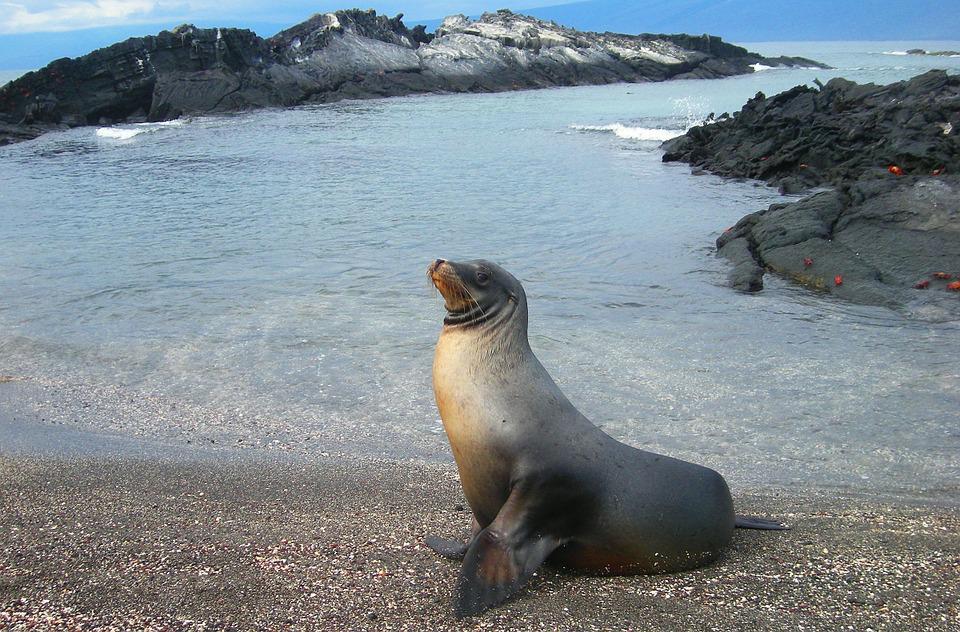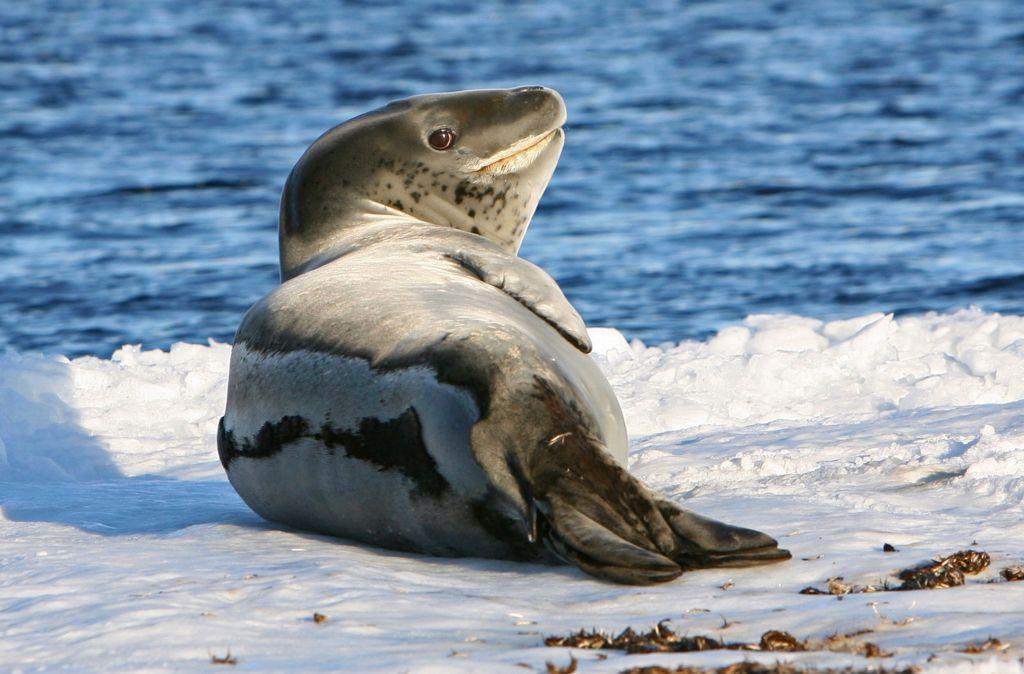The first image is the image on the left, the second image is the image on the right. Considering the images on both sides, is "Each image shows exactly one seal with raised head and water in the background, and one of the depicted seals faces left, while the other faces right." valid? Answer yes or no. Yes. The first image is the image on the left, the second image is the image on the right. Evaluate the accuracy of this statement regarding the images: "The right image contains at least two seals.". Is it true? Answer yes or no. No. 